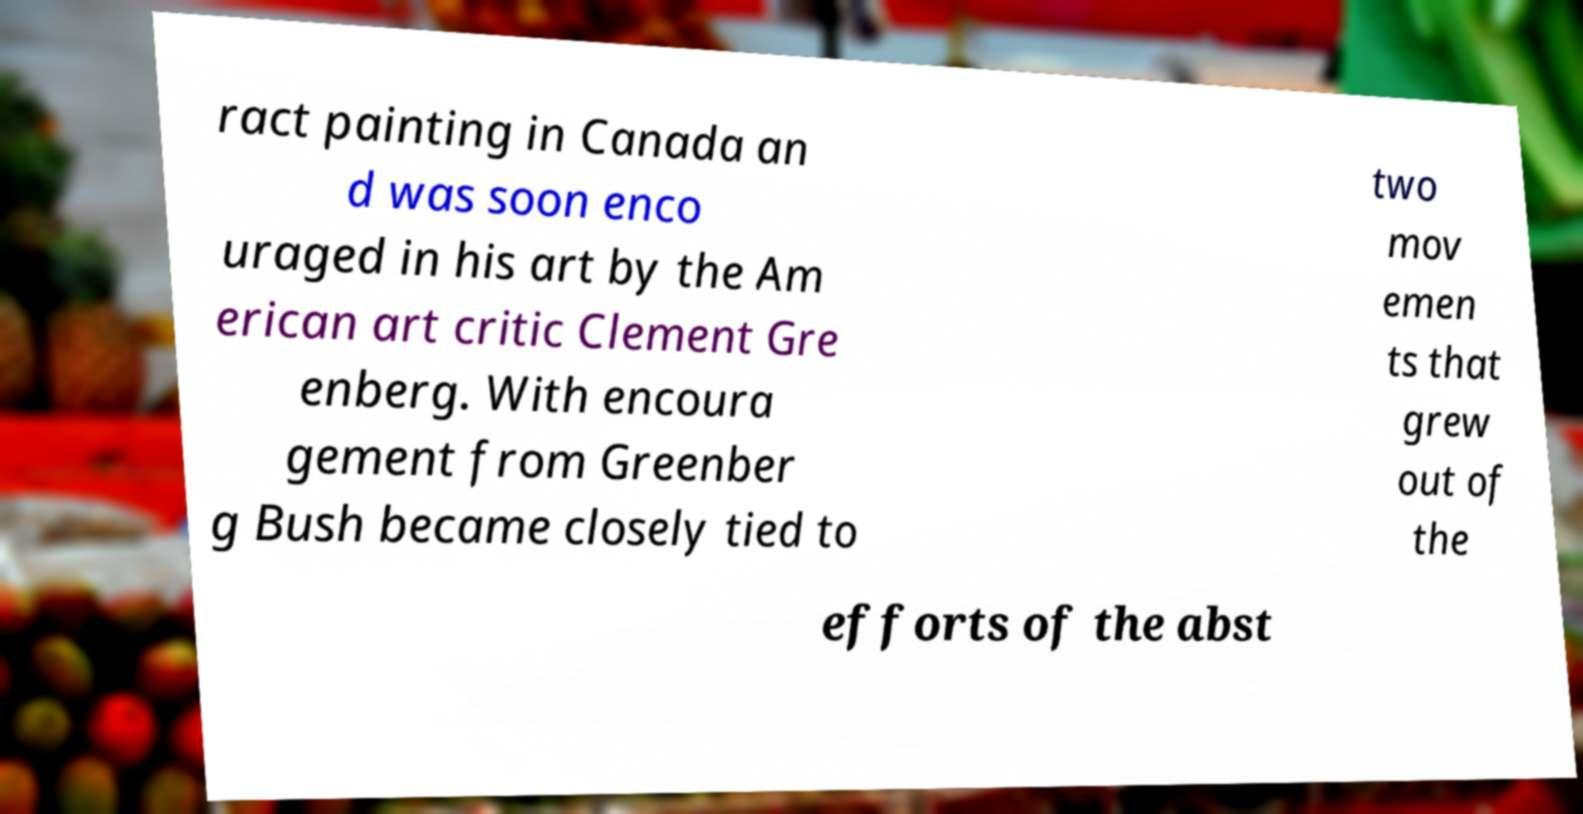What messages or text are displayed in this image? I need them in a readable, typed format. ract painting in Canada an d was soon enco uraged in his art by the Am erican art critic Clement Gre enberg. With encoura gement from Greenber g Bush became closely tied to two mov emen ts that grew out of the efforts of the abst 